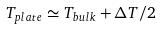<formula> <loc_0><loc_0><loc_500><loc_500>T _ { p l a t e } \simeq T _ { b u l k } + \Delta T / 2</formula> 